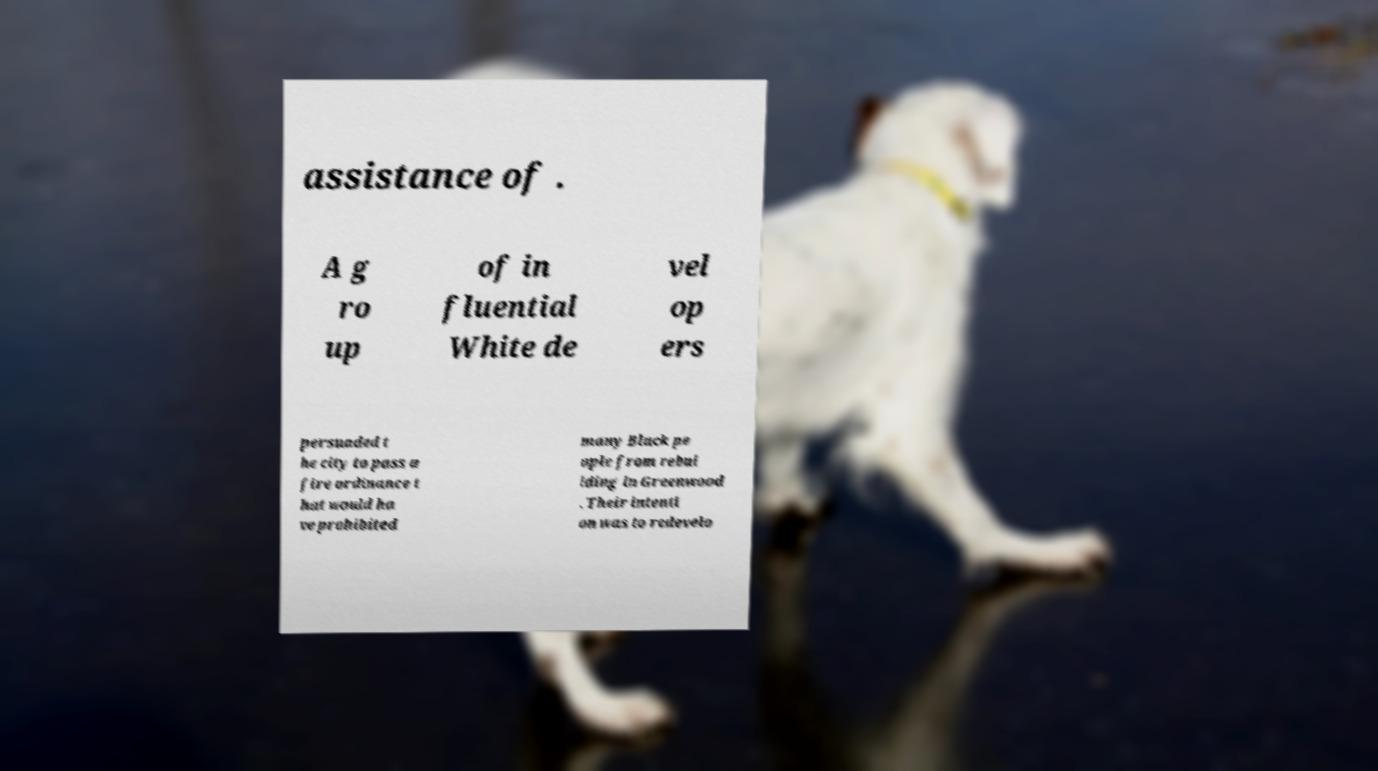What messages or text are displayed in this image? I need them in a readable, typed format. assistance of . A g ro up of in fluential White de vel op ers persuaded t he city to pass a fire ordinance t hat would ha ve prohibited many Black pe ople from rebui lding in Greenwood . Their intenti on was to redevelo 